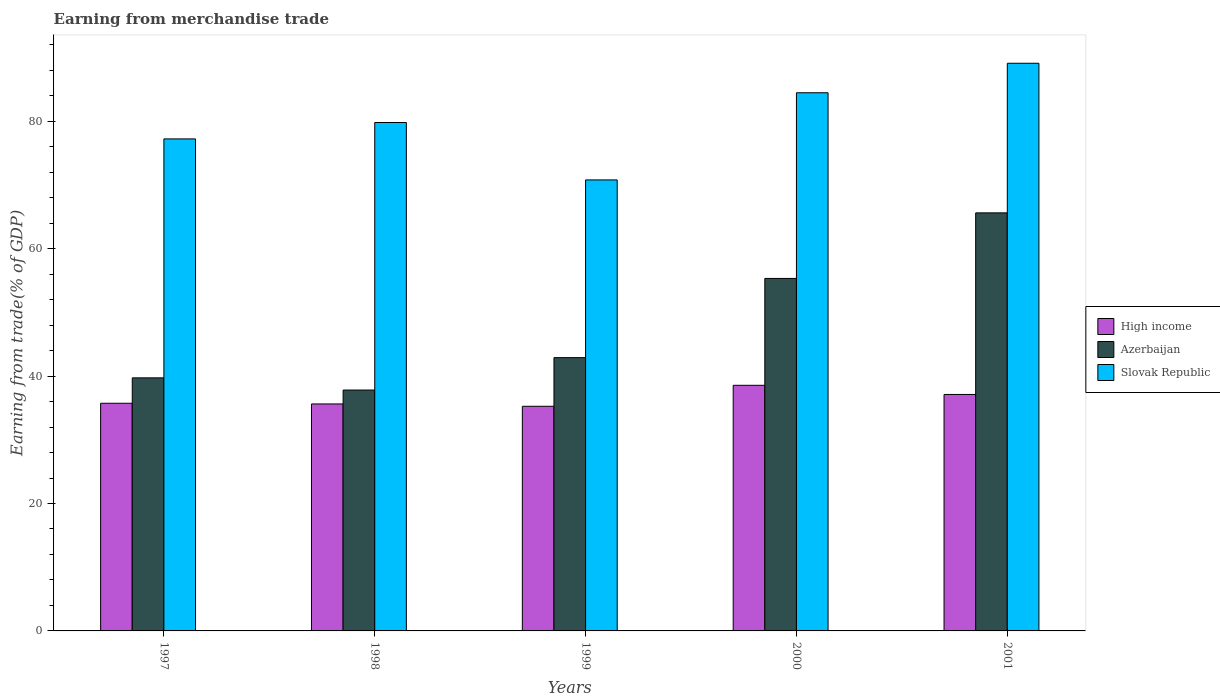Are the number of bars on each tick of the X-axis equal?
Your response must be concise. Yes. How many bars are there on the 4th tick from the right?
Ensure brevity in your answer.  3. In how many cases, is the number of bars for a given year not equal to the number of legend labels?
Your answer should be very brief. 0. What is the earnings from trade in High income in 2000?
Provide a short and direct response. 38.55. Across all years, what is the maximum earnings from trade in High income?
Provide a succinct answer. 38.55. Across all years, what is the minimum earnings from trade in High income?
Offer a terse response. 35.26. In which year was the earnings from trade in Slovak Republic maximum?
Offer a terse response. 2001. In which year was the earnings from trade in Slovak Republic minimum?
Provide a succinct answer. 1999. What is the total earnings from trade in Slovak Republic in the graph?
Offer a terse response. 401.36. What is the difference between the earnings from trade in High income in 1998 and that in 2000?
Give a very brief answer. -2.93. What is the difference between the earnings from trade in Slovak Republic in 2000 and the earnings from trade in High income in 1998?
Provide a succinct answer. 48.84. What is the average earnings from trade in Azerbaijan per year?
Your answer should be very brief. 48.27. In the year 1997, what is the difference between the earnings from trade in Azerbaijan and earnings from trade in Slovak Republic?
Keep it short and to the point. -37.5. What is the ratio of the earnings from trade in Azerbaijan in 1997 to that in 1998?
Make the answer very short. 1.05. Is the earnings from trade in Azerbaijan in 1999 less than that in 2001?
Your answer should be very brief. Yes. Is the difference between the earnings from trade in Azerbaijan in 1997 and 2000 greater than the difference between the earnings from trade in Slovak Republic in 1997 and 2000?
Your response must be concise. No. What is the difference between the highest and the second highest earnings from trade in Slovak Republic?
Your response must be concise. 4.63. What is the difference between the highest and the lowest earnings from trade in Azerbaijan?
Offer a terse response. 27.81. In how many years, is the earnings from trade in Slovak Republic greater than the average earnings from trade in Slovak Republic taken over all years?
Make the answer very short. 2. Is the sum of the earnings from trade in Azerbaijan in 1997 and 1999 greater than the maximum earnings from trade in Slovak Republic across all years?
Give a very brief answer. No. What does the 2nd bar from the right in 2000 represents?
Keep it short and to the point. Azerbaijan. How many bars are there?
Provide a succinct answer. 15. How many years are there in the graph?
Ensure brevity in your answer.  5. What is the difference between two consecutive major ticks on the Y-axis?
Provide a succinct answer. 20. Does the graph contain grids?
Your answer should be very brief. No. Where does the legend appear in the graph?
Keep it short and to the point. Center right. How are the legend labels stacked?
Provide a succinct answer. Vertical. What is the title of the graph?
Your answer should be very brief. Earning from merchandise trade. Does "Kazakhstan" appear as one of the legend labels in the graph?
Offer a terse response. No. What is the label or title of the X-axis?
Ensure brevity in your answer.  Years. What is the label or title of the Y-axis?
Provide a succinct answer. Earning from trade(% of GDP). What is the Earning from trade(% of GDP) in High income in 1997?
Ensure brevity in your answer.  35.73. What is the Earning from trade(% of GDP) of Azerbaijan in 1997?
Ensure brevity in your answer.  39.72. What is the Earning from trade(% of GDP) of Slovak Republic in 1997?
Ensure brevity in your answer.  77.22. What is the Earning from trade(% of GDP) of High income in 1998?
Your response must be concise. 35.62. What is the Earning from trade(% of GDP) of Azerbaijan in 1998?
Your answer should be compact. 37.81. What is the Earning from trade(% of GDP) in Slovak Republic in 1998?
Provide a short and direct response. 79.8. What is the Earning from trade(% of GDP) of High income in 1999?
Keep it short and to the point. 35.26. What is the Earning from trade(% of GDP) of Azerbaijan in 1999?
Your response must be concise. 42.89. What is the Earning from trade(% of GDP) of Slovak Republic in 1999?
Keep it short and to the point. 70.79. What is the Earning from trade(% of GDP) in High income in 2000?
Your answer should be very brief. 38.55. What is the Earning from trade(% of GDP) of Azerbaijan in 2000?
Provide a succinct answer. 55.32. What is the Earning from trade(% of GDP) of Slovak Republic in 2000?
Ensure brevity in your answer.  84.46. What is the Earning from trade(% of GDP) of High income in 2001?
Provide a succinct answer. 37.11. What is the Earning from trade(% of GDP) in Azerbaijan in 2001?
Provide a succinct answer. 65.61. What is the Earning from trade(% of GDP) of Slovak Republic in 2001?
Offer a very short reply. 89.1. Across all years, what is the maximum Earning from trade(% of GDP) of High income?
Ensure brevity in your answer.  38.55. Across all years, what is the maximum Earning from trade(% of GDP) in Azerbaijan?
Provide a succinct answer. 65.61. Across all years, what is the maximum Earning from trade(% of GDP) of Slovak Republic?
Offer a terse response. 89.1. Across all years, what is the minimum Earning from trade(% of GDP) of High income?
Provide a succinct answer. 35.26. Across all years, what is the minimum Earning from trade(% of GDP) of Azerbaijan?
Ensure brevity in your answer.  37.81. Across all years, what is the minimum Earning from trade(% of GDP) of Slovak Republic?
Make the answer very short. 70.79. What is the total Earning from trade(% of GDP) of High income in the graph?
Keep it short and to the point. 182.28. What is the total Earning from trade(% of GDP) in Azerbaijan in the graph?
Your response must be concise. 241.36. What is the total Earning from trade(% of GDP) of Slovak Republic in the graph?
Offer a terse response. 401.36. What is the difference between the Earning from trade(% of GDP) in High income in 1997 and that in 1998?
Your answer should be compact. 0.11. What is the difference between the Earning from trade(% of GDP) in Azerbaijan in 1997 and that in 1998?
Offer a terse response. 1.91. What is the difference between the Earning from trade(% of GDP) of Slovak Republic in 1997 and that in 1998?
Provide a succinct answer. -2.57. What is the difference between the Earning from trade(% of GDP) in High income in 1997 and that in 1999?
Give a very brief answer. 0.47. What is the difference between the Earning from trade(% of GDP) in Azerbaijan in 1997 and that in 1999?
Offer a terse response. -3.17. What is the difference between the Earning from trade(% of GDP) of Slovak Republic in 1997 and that in 1999?
Your answer should be very brief. 6.44. What is the difference between the Earning from trade(% of GDP) of High income in 1997 and that in 2000?
Your response must be concise. -2.82. What is the difference between the Earning from trade(% of GDP) in Azerbaijan in 1997 and that in 2000?
Make the answer very short. -15.6. What is the difference between the Earning from trade(% of GDP) of Slovak Republic in 1997 and that in 2000?
Provide a short and direct response. -7.24. What is the difference between the Earning from trade(% of GDP) in High income in 1997 and that in 2001?
Your answer should be compact. -1.38. What is the difference between the Earning from trade(% of GDP) in Azerbaijan in 1997 and that in 2001?
Provide a short and direct response. -25.89. What is the difference between the Earning from trade(% of GDP) in Slovak Republic in 1997 and that in 2001?
Your answer should be compact. -11.87. What is the difference between the Earning from trade(% of GDP) in High income in 1998 and that in 1999?
Make the answer very short. 0.36. What is the difference between the Earning from trade(% of GDP) of Azerbaijan in 1998 and that in 1999?
Your response must be concise. -5.09. What is the difference between the Earning from trade(% of GDP) in Slovak Republic in 1998 and that in 1999?
Your answer should be very brief. 9.01. What is the difference between the Earning from trade(% of GDP) in High income in 1998 and that in 2000?
Ensure brevity in your answer.  -2.93. What is the difference between the Earning from trade(% of GDP) of Azerbaijan in 1998 and that in 2000?
Provide a succinct answer. -17.52. What is the difference between the Earning from trade(% of GDP) in Slovak Republic in 1998 and that in 2000?
Provide a succinct answer. -4.67. What is the difference between the Earning from trade(% of GDP) of High income in 1998 and that in 2001?
Your answer should be very brief. -1.49. What is the difference between the Earning from trade(% of GDP) in Azerbaijan in 1998 and that in 2001?
Offer a very short reply. -27.81. What is the difference between the Earning from trade(% of GDP) in Slovak Republic in 1998 and that in 2001?
Provide a succinct answer. -9.3. What is the difference between the Earning from trade(% of GDP) in High income in 1999 and that in 2000?
Offer a terse response. -3.29. What is the difference between the Earning from trade(% of GDP) in Azerbaijan in 1999 and that in 2000?
Offer a terse response. -12.43. What is the difference between the Earning from trade(% of GDP) of Slovak Republic in 1999 and that in 2000?
Your answer should be compact. -13.68. What is the difference between the Earning from trade(% of GDP) in High income in 1999 and that in 2001?
Offer a very short reply. -1.85. What is the difference between the Earning from trade(% of GDP) in Azerbaijan in 1999 and that in 2001?
Offer a very short reply. -22.72. What is the difference between the Earning from trade(% of GDP) of Slovak Republic in 1999 and that in 2001?
Provide a short and direct response. -18.31. What is the difference between the Earning from trade(% of GDP) in High income in 2000 and that in 2001?
Provide a succinct answer. 1.44. What is the difference between the Earning from trade(% of GDP) of Azerbaijan in 2000 and that in 2001?
Offer a very short reply. -10.29. What is the difference between the Earning from trade(% of GDP) in Slovak Republic in 2000 and that in 2001?
Ensure brevity in your answer.  -4.63. What is the difference between the Earning from trade(% of GDP) in High income in 1997 and the Earning from trade(% of GDP) in Azerbaijan in 1998?
Your answer should be very brief. -2.07. What is the difference between the Earning from trade(% of GDP) of High income in 1997 and the Earning from trade(% of GDP) of Slovak Republic in 1998?
Offer a terse response. -44.06. What is the difference between the Earning from trade(% of GDP) of Azerbaijan in 1997 and the Earning from trade(% of GDP) of Slovak Republic in 1998?
Your answer should be compact. -40.07. What is the difference between the Earning from trade(% of GDP) of High income in 1997 and the Earning from trade(% of GDP) of Azerbaijan in 1999?
Offer a terse response. -7.16. What is the difference between the Earning from trade(% of GDP) in High income in 1997 and the Earning from trade(% of GDP) in Slovak Republic in 1999?
Make the answer very short. -35.06. What is the difference between the Earning from trade(% of GDP) of Azerbaijan in 1997 and the Earning from trade(% of GDP) of Slovak Republic in 1999?
Offer a terse response. -31.07. What is the difference between the Earning from trade(% of GDP) of High income in 1997 and the Earning from trade(% of GDP) of Azerbaijan in 2000?
Keep it short and to the point. -19.59. What is the difference between the Earning from trade(% of GDP) of High income in 1997 and the Earning from trade(% of GDP) of Slovak Republic in 2000?
Offer a very short reply. -48.73. What is the difference between the Earning from trade(% of GDP) in Azerbaijan in 1997 and the Earning from trade(% of GDP) in Slovak Republic in 2000?
Your answer should be very brief. -44.74. What is the difference between the Earning from trade(% of GDP) in High income in 1997 and the Earning from trade(% of GDP) in Azerbaijan in 2001?
Provide a short and direct response. -29.88. What is the difference between the Earning from trade(% of GDP) of High income in 1997 and the Earning from trade(% of GDP) of Slovak Republic in 2001?
Give a very brief answer. -53.36. What is the difference between the Earning from trade(% of GDP) of Azerbaijan in 1997 and the Earning from trade(% of GDP) of Slovak Republic in 2001?
Offer a very short reply. -49.38. What is the difference between the Earning from trade(% of GDP) in High income in 1998 and the Earning from trade(% of GDP) in Azerbaijan in 1999?
Offer a very short reply. -7.27. What is the difference between the Earning from trade(% of GDP) of High income in 1998 and the Earning from trade(% of GDP) of Slovak Republic in 1999?
Give a very brief answer. -35.16. What is the difference between the Earning from trade(% of GDP) in Azerbaijan in 1998 and the Earning from trade(% of GDP) in Slovak Republic in 1999?
Offer a very short reply. -32.98. What is the difference between the Earning from trade(% of GDP) of High income in 1998 and the Earning from trade(% of GDP) of Azerbaijan in 2000?
Offer a very short reply. -19.7. What is the difference between the Earning from trade(% of GDP) in High income in 1998 and the Earning from trade(% of GDP) in Slovak Republic in 2000?
Offer a terse response. -48.84. What is the difference between the Earning from trade(% of GDP) in Azerbaijan in 1998 and the Earning from trade(% of GDP) in Slovak Republic in 2000?
Offer a terse response. -46.66. What is the difference between the Earning from trade(% of GDP) in High income in 1998 and the Earning from trade(% of GDP) in Azerbaijan in 2001?
Your response must be concise. -29.99. What is the difference between the Earning from trade(% of GDP) of High income in 1998 and the Earning from trade(% of GDP) of Slovak Republic in 2001?
Keep it short and to the point. -53.47. What is the difference between the Earning from trade(% of GDP) in Azerbaijan in 1998 and the Earning from trade(% of GDP) in Slovak Republic in 2001?
Your response must be concise. -51.29. What is the difference between the Earning from trade(% of GDP) of High income in 1999 and the Earning from trade(% of GDP) of Azerbaijan in 2000?
Give a very brief answer. -20.06. What is the difference between the Earning from trade(% of GDP) in High income in 1999 and the Earning from trade(% of GDP) in Slovak Republic in 2000?
Offer a terse response. -49.2. What is the difference between the Earning from trade(% of GDP) of Azerbaijan in 1999 and the Earning from trade(% of GDP) of Slovak Republic in 2000?
Offer a terse response. -41.57. What is the difference between the Earning from trade(% of GDP) of High income in 1999 and the Earning from trade(% of GDP) of Azerbaijan in 2001?
Ensure brevity in your answer.  -30.35. What is the difference between the Earning from trade(% of GDP) in High income in 1999 and the Earning from trade(% of GDP) in Slovak Republic in 2001?
Offer a very short reply. -53.84. What is the difference between the Earning from trade(% of GDP) in Azerbaijan in 1999 and the Earning from trade(% of GDP) in Slovak Republic in 2001?
Give a very brief answer. -46.2. What is the difference between the Earning from trade(% of GDP) of High income in 2000 and the Earning from trade(% of GDP) of Azerbaijan in 2001?
Provide a succinct answer. -27.06. What is the difference between the Earning from trade(% of GDP) of High income in 2000 and the Earning from trade(% of GDP) of Slovak Republic in 2001?
Make the answer very short. -50.55. What is the difference between the Earning from trade(% of GDP) in Azerbaijan in 2000 and the Earning from trade(% of GDP) in Slovak Republic in 2001?
Give a very brief answer. -33.77. What is the average Earning from trade(% of GDP) of High income per year?
Give a very brief answer. 36.46. What is the average Earning from trade(% of GDP) of Azerbaijan per year?
Make the answer very short. 48.27. What is the average Earning from trade(% of GDP) of Slovak Republic per year?
Provide a short and direct response. 80.27. In the year 1997, what is the difference between the Earning from trade(% of GDP) of High income and Earning from trade(% of GDP) of Azerbaijan?
Give a very brief answer. -3.99. In the year 1997, what is the difference between the Earning from trade(% of GDP) of High income and Earning from trade(% of GDP) of Slovak Republic?
Make the answer very short. -41.49. In the year 1997, what is the difference between the Earning from trade(% of GDP) in Azerbaijan and Earning from trade(% of GDP) in Slovak Republic?
Your answer should be very brief. -37.5. In the year 1998, what is the difference between the Earning from trade(% of GDP) of High income and Earning from trade(% of GDP) of Azerbaijan?
Offer a very short reply. -2.18. In the year 1998, what is the difference between the Earning from trade(% of GDP) of High income and Earning from trade(% of GDP) of Slovak Republic?
Provide a short and direct response. -44.17. In the year 1998, what is the difference between the Earning from trade(% of GDP) in Azerbaijan and Earning from trade(% of GDP) in Slovak Republic?
Your answer should be very brief. -41.99. In the year 1999, what is the difference between the Earning from trade(% of GDP) of High income and Earning from trade(% of GDP) of Azerbaijan?
Provide a succinct answer. -7.63. In the year 1999, what is the difference between the Earning from trade(% of GDP) of High income and Earning from trade(% of GDP) of Slovak Republic?
Offer a very short reply. -35.53. In the year 1999, what is the difference between the Earning from trade(% of GDP) of Azerbaijan and Earning from trade(% of GDP) of Slovak Republic?
Provide a short and direct response. -27.89. In the year 2000, what is the difference between the Earning from trade(% of GDP) of High income and Earning from trade(% of GDP) of Azerbaijan?
Give a very brief answer. -16.77. In the year 2000, what is the difference between the Earning from trade(% of GDP) in High income and Earning from trade(% of GDP) in Slovak Republic?
Provide a succinct answer. -45.91. In the year 2000, what is the difference between the Earning from trade(% of GDP) of Azerbaijan and Earning from trade(% of GDP) of Slovak Republic?
Give a very brief answer. -29.14. In the year 2001, what is the difference between the Earning from trade(% of GDP) of High income and Earning from trade(% of GDP) of Azerbaijan?
Your response must be concise. -28.5. In the year 2001, what is the difference between the Earning from trade(% of GDP) of High income and Earning from trade(% of GDP) of Slovak Republic?
Keep it short and to the point. -51.98. In the year 2001, what is the difference between the Earning from trade(% of GDP) in Azerbaijan and Earning from trade(% of GDP) in Slovak Republic?
Offer a terse response. -23.48. What is the ratio of the Earning from trade(% of GDP) of High income in 1997 to that in 1998?
Offer a very short reply. 1. What is the ratio of the Earning from trade(% of GDP) in Azerbaijan in 1997 to that in 1998?
Your response must be concise. 1.05. What is the ratio of the Earning from trade(% of GDP) of Slovak Republic in 1997 to that in 1998?
Give a very brief answer. 0.97. What is the ratio of the Earning from trade(% of GDP) of High income in 1997 to that in 1999?
Keep it short and to the point. 1.01. What is the ratio of the Earning from trade(% of GDP) in Azerbaijan in 1997 to that in 1999?
Make the answer very short. 0.93. What is the ratio of the Earning from trade(% of GDP) in High income in 1997 to that in 2000?
Ensure brevity in your answer.  0.93. What is the ratio of the Earning from trade(% of GDP) of Azerbaijan in 1997 to that in 2000?
Offer a terse response. 0.72. What is the ratio of the Earning from trade(% of GDP) in Slovak Republic in 1997 to that in 2000?
Ensure brevity in your answer.  0.91. What is the ratio of the Earning from trade(% of GDP) of High income in 1997 to that in 2001?
Your response must be concise. 0.96. What is the ratio of the Earning from trade(% of GDP) of Azerbaijan in 1997 to that in 2001?
Provide a short and direct response. 0.61. What is the ratio of the Earning from trade(% of GDP) in Slovak Republic in 1997 to that in 2001?
Offer a terse response. 0.87. What is the ratio of the Earning from trade(% of GDP) in High income in 1998 to that in 1999?
Your answer should be compact. 1.01. What is the ratio of the Earning from trade(% of GDP) of Azerbaijan in 1998 to that in 1999?
Your answer should be very brief. 0.88. What is the ratio of the Earning from trade(% of GDP) of Slovak Republic in 1998 to that in 1999?
Your answer should be compact. 1.13. What is the ratio of the Earning from trade(% of GDP) in High income in 1998 to that in 2000?
Make the answer very short. 0.92. What is the ratio of the Earning from trade(% of GDP) in Azerbaijan in 1998 to that in 2000?
Your answer should be very brief. 0.68. What is the ratio of the Earning from trade(% of GDP) in Slovak Republic in 1998 to that in 2000?
Ensure brevity in your answer.  0.94. What is the ratio of the Earning from trade(% of GDP) of High income in 1998 to that in 2001?
Provide a succinct answer. 0.96. What is the ratio of the Earning from trade(% of GDP) of Azerbaijan in 1998 to that in 2001?
Make the answer very short. 0.58. What is the ratio of the Earning from trade(% of GDP) in Slovak Republic in 1998 to that in 2001?
Give a very brief answer. 0.9. What is the ratio of the Earning from trade(% of GDP) in High income in 1999 to that in 2000?
Provide a succinct answer. 0.91. What is the ratio of the Earning from trade(% of GDP) in Azerbaijan in 1999 to that in 2000?
Provide a short and direct response. 0.78. What is the ratio of the Earning from trade(% of GDP) in Slovak Republic in 1999 to that in 2000?
Your answer should be compact. 0.84. What is the ratio of the Earning from trade(% of GDP) in High income in 1999 to that in 2001?
Keep it short and to the point. 0.95. What is the ratio of the Earning from trade(% of GDP) of Azerbaijan in 1999 to that in 2001?
Offer a very short reply. 0.65. What is the ratio of the Earning from trade(% of GDP) of Slovak Republic in 1999 to that in 2001?
Give a very brief answer. 0.79. What is the ratio of the Earning from trade(% of GDP) in High income in 2000 to that in 2001?
Your answer should be very brief. 1.04. What is the ratio of the Earning from trade(% of GDP) in Azerbaijan in 2000 to that in 2001?
Your answer should be compact. 0.84. What is the ratio of the Earning from trade(% of GDP) in Slovak Republic in 2000 to that in 2001?
Your answer should be very brief. 0.95. What is the difference between the highest and the second highest Earning from trade(% of GDP) in High income?
Your answer should be very brief. 1.44. What is the difference between the highest and the second highest Earning from trade(% of GDP) in Azerbaijan?
Provide a short and direct response. 10.29. What is the difference between the highest and the second highest Earning from trade(% of GDP) in Slovak Republic?
Your answer should be compact. 4.63. What is the difference between the highest and the lowest Earning from trade(% of GDP) of High income?
Keep it short and to the point. 3.29. What is the difference between the highest and the lowest Earning from trade(% of GDP) in Azerbaijan?
Provide a short and direct response. 27.81. What is the difference between the highest and the lowest Earning from trade(% of GDP) in Slovak Republic?
Your response must be concise. 18.31. 